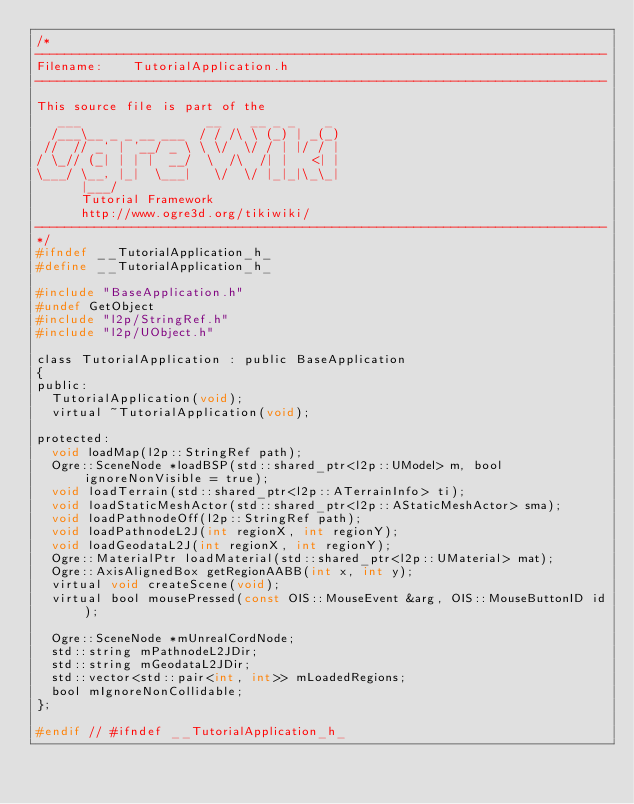Convert code to text. <code><loc_0><loc_0><loc_500><loc_500><_C_>/*
-----------------------------------------------------------------------------
Filename:    TutorialApplication.h
-----------------------------------------------------------------------------

This source file is part of the
   ___                 __    __ _ _    _
  /___\__ _ _ __ ___  / / /\ \ (_) | _(_)
 //  // _` | '__/ _ \ \ \/  \/ / | |/ / |
/ \_// (_| | | |  __/  \  /\  /| |   <| |
\___/ \__, |_|  \___|   \/  \/ |_|_|\_\_|
      |___/
      Tutorial Framework
      http://www.ogre3d.org/tikiwiki/
-----------------------------------------------------------------------------
*/
#ifndef __TutorialApplication_h_
#define __TutorialApplication_h_

#include "BaseApplication.h"
#undef GetObject
#include "l2p/StringRef.h"
#include "l2p/UObject.h"

class TutorialApplication : public BaseApplication
{
public:
  TutorialApplication(void);
  virtual ~TutorialApplication(void);

protected:
  void loadMap(l2p::StringRef path);
  Ogre::SceneNode *loadBSP(std::shared_ptr<l2p::UModel> m, bool ignoreNonVisible = true);
  void loadTerrain(std::shared_ptr<l2p::ATerrainInfo> ti);
  void loadStaticMeshActor(std::shared_ptr<l2p::AStaticMeshActor> sma);
  void loadPathnodeOff(l2p::StringRef path);
  void loadPathnodeL2J(int regionX, int regionY);
  void loadGeodataL2J(int regionX, int regionY);
  Ogre::MaterialPtr loadMaterial(std::shared_ptr<l2p::UMaterial> mat);
  Ogre::AxisAlignedBox getRegionAABB(int x, int y);
  virtual void createScene(void);
  virtual bool mousePressed(const OIS::MouseEvent &arg, OIS::MouseButtonID id);

  Ogre::SceneNode *mUnrealCordNode;
  std::string mPathnodeL2JDir;
  std::string mGeodataL2JDir;
  std::vector<std::pair<int, int>> mLoadedRegions;
  bool mIgnoreNonCollidable;
};

#endif // #ifndef __TutorialApplication_h_
</code> 